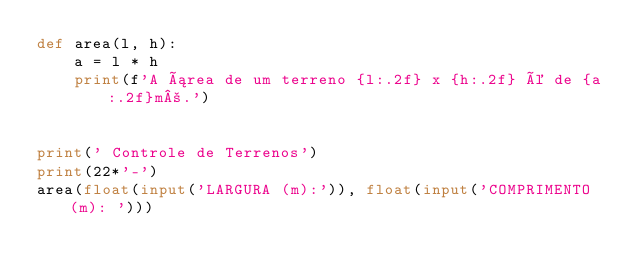<code> <loc_0><loc_0><loc_500><loc_500><_Python_>def area(l, h):
    a = l * h
    print(f'A área de um terreno {l:.2f} x {h:.2f} é de {a:.2f}m².')


print(' Controle de Terrenos')
print(22*'-')
area(float(input('LARGURA (m):')), float(input('COMPRIMENTO (m): ')))
</code> 